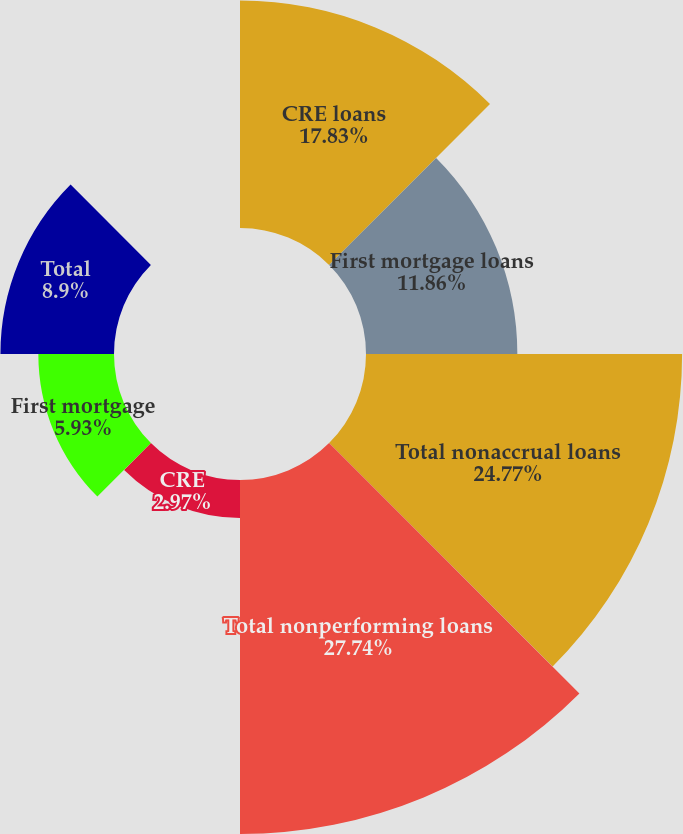Convert chart to OTSL. <chart><loc_0><loc_0><loc_500><loc_500><pie_chart><fcel>CRE loans<fcel>First mortgage loans<fcel>Total nonaccrual loans<fcel>Total nonperforming loans<fcel>CRE<fcel>First mortgage<fcel>Total<fcel>Total nonperforming assets net<nl><fcel>17.83%<fcel>11.86%<fcel>24.77%<fcel>27.74%<fcel>2.97%<fcel>5.93%<fcel>8.9%<fcel>0.0%<nl></chart> 